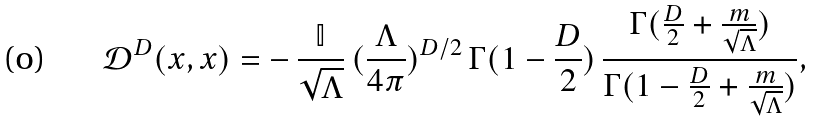Convert formula to latex. <formula><loc_0><loc_0><loc_500><loc_500>\mathcal { D } ^ { D } ( x , x ) = - \, \frac { \mathbb { I } } { \sqrt { \Lambda } } \, ( \frac { \Lambda } { 4 \pi } ) ^ { D / 2 } \, \Gamma ( 1 - \frac { D } { 2 } ) \, \frac { \Gamma ( \frac { D } { 2 } + \frac { m } { \sqrt { \Lambda } } ) } { \Gamma ( 1 - \frac { D } { 2 } + \frac { m } { \sqrt { \Lambda } } ) } ,</formula> 